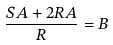Convert formula to latex. <formula><loc_0><loc_0><loc_500><loc_500>\frac { S A + 2 R A } { R } = B</formula> 